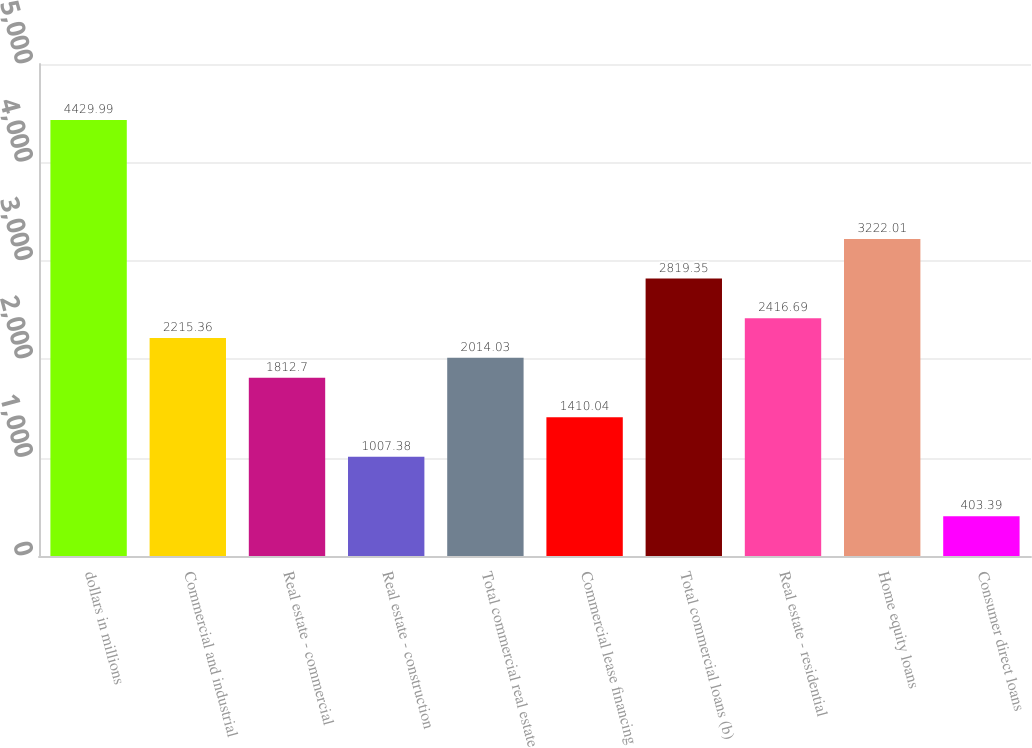Convert chart. <chart><loc_0><loc_0><loc_500><loc_500><bar_chart><fcel>dollars in millions<fcel>Commercial and industrial<fcel>Real estate - commercial<fcel>Real estate - construction<fcel>Total commercial real estate<fcel>Commercial lease financing<fcel>Total commercial loans (b)<fcel>Real estate - residential<fcel>Home equity loans<fcel>Consumer direct loans<nl><fcel>4429.99<fcel>2215.36<fcel>1812.7<fcel>1007.38<fcel>2014.03<fcel>1410.04<fcel>2819.35<fcel>2416.69<fcel>3222.01<fcel>403.39<nl></chart> 